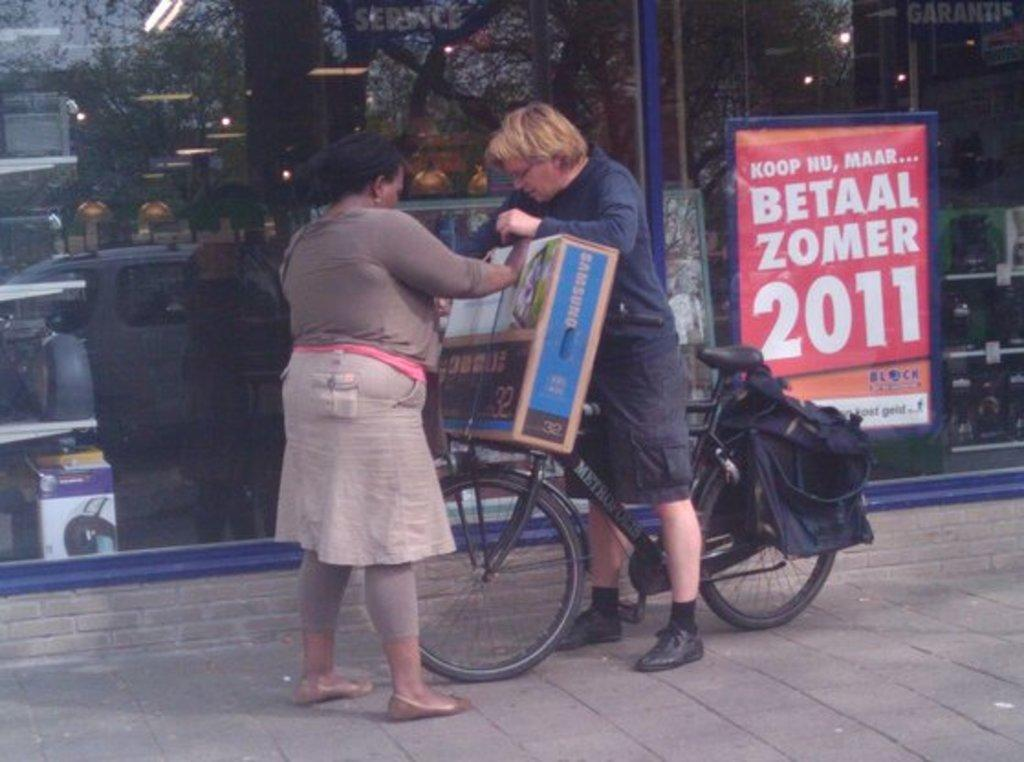How many people are in the image? A: There are two members in the image. What is one of the members doing in the image? One of them is on a bicycle. What is the person on the bicycle holding? The person on the bicycle is holding a box. What can be seen in the background of the image? There is a poster in the background of the image. How is the poster positioned in the image? The poster is attached to a glass surface. What type of truck can be seen in the image? There is no truck present in the image. What is the person on the bicycle holding in their other hand, besides the box? The person on the bicycle is not holding anything else in their other hand besides the box, as it is not visible in the image. 